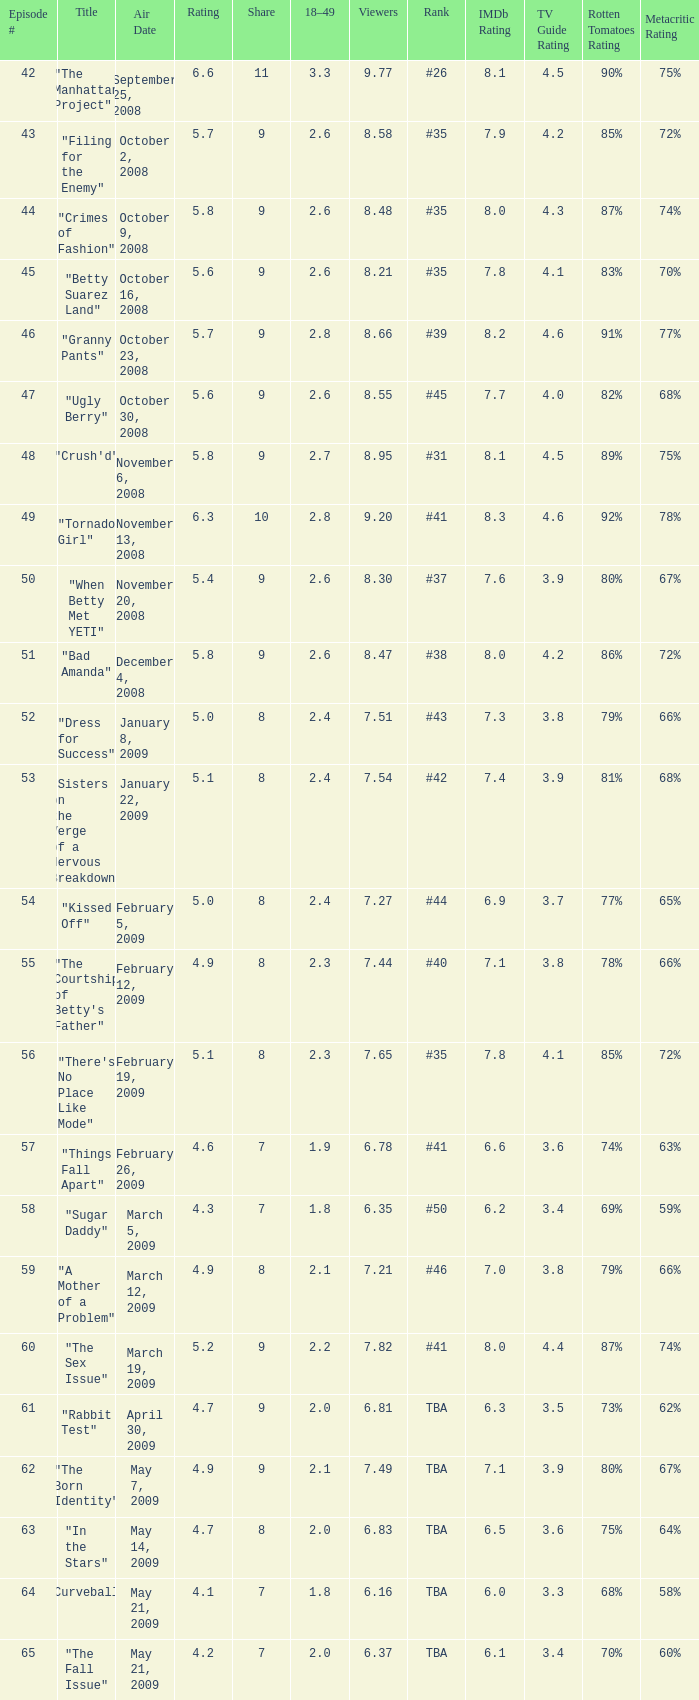What is the lowest Viewers that has an Episode #higher than 58 with a title of "curveball" less than 4.1 rating? None. 